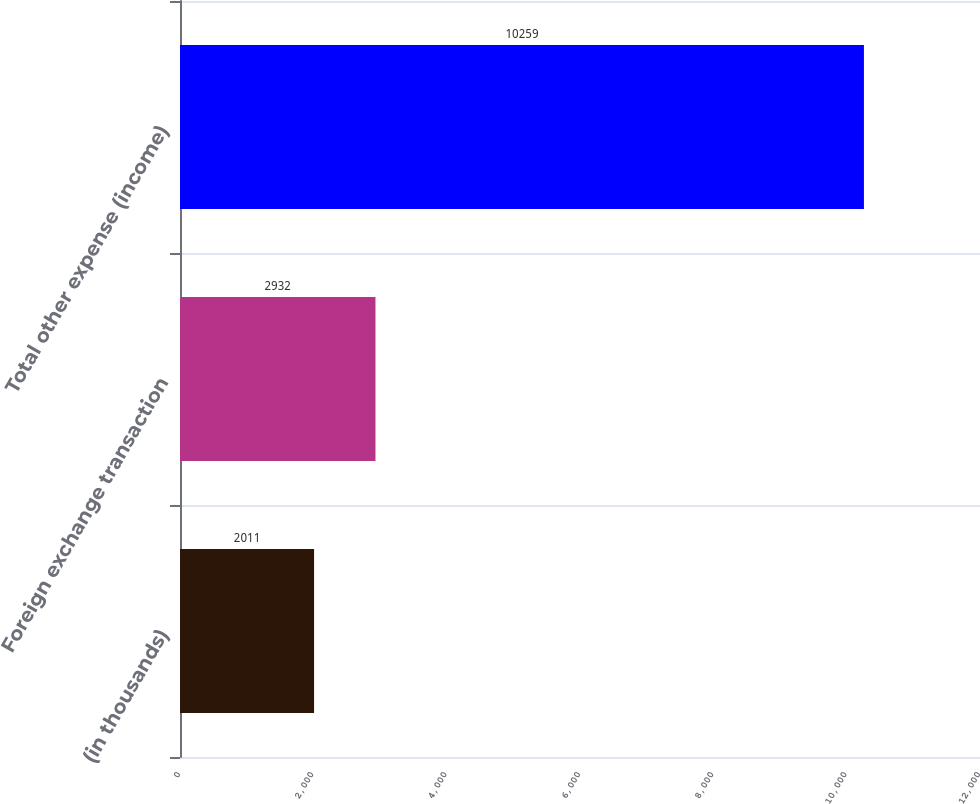Convert chart. <chart><loc_0><loc_0><loc_500><loc_500><bar_chart><fcel>(in thousands)<fcel>Foreign exchange transaction<fcel>Total other expense (income)<nl><fcel>2011<fcel>2932<fcel>10259<nl></chart> 